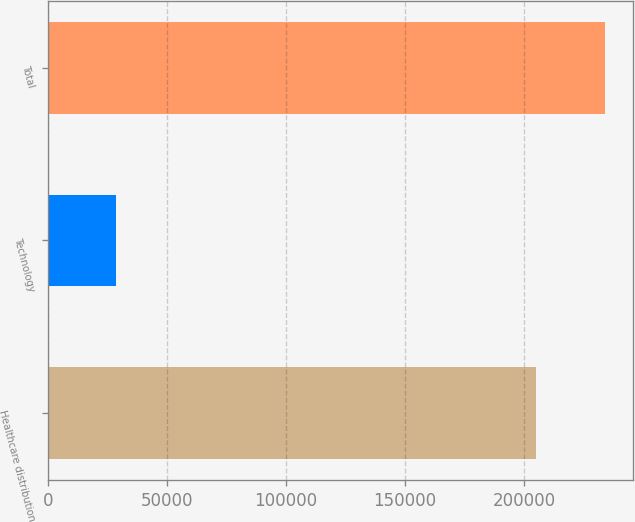Convert chart. <chart><loc_0><loc_0><loc_500><loc_500><bar_chart><fcel>Healthcare distribution<fcel>Technology<fcel>Total<nl><fcel>205029<fcel>28690<fcel>233719<nl></chart> 